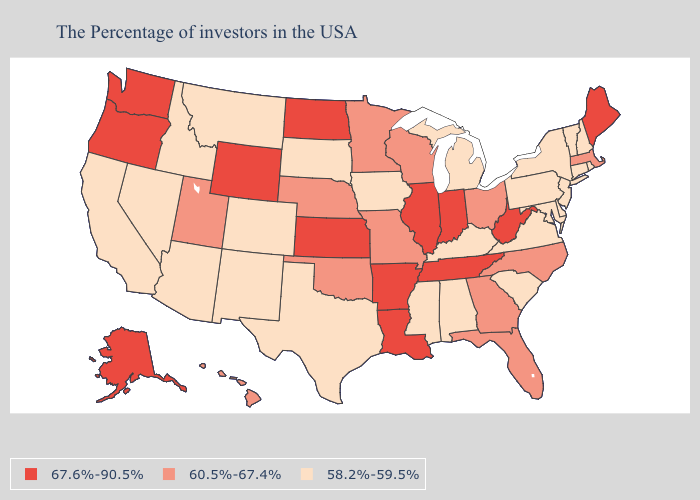Name the states that have a value in the range 60.5%-67.4%?
Keep it brief. Massachusetts, North Carolina, Ohio, Florida, Georgia, Wisconsin, Missouri, Minnesota, Nebraska, Oklahoma, Utah, Hawaii. Name the states that have a value in the range 60.5%-67.4%?
Be succinct. Massachusetts, North Carolina, Ohio, Florida, Georgia, Wisconsin, Missouri, Minnesota, Nebraska, Oklahoma, Utah, Hawaii. Does Rhode Island have a higher value than Montana?
Concise answer only. No. What is the value of Kansas?
Write a very short answer. 67.6%-90.5%. Among the states that border Colorado , does Nebraska have the highest value?
Be succinct. No. Does the first symbol in the legend represent the smallest category?
Quick response, please. No. What is the lowest value in the USA?
Write a very short answer. 58.2%-59.5%. What is the value of Maryland?
Concise answer only. 58.2%-59.5%. Name the states that have a value in the range 60.5%-67.4%?
Quick response, please. Massachusetts, North Carolina, Ohio, Florida, Georgia, Wisconsin, Missouri, Minnesota, Nebraska, Oklahoma, Utah, Hawaii. What is the value of Louisiana?
Write a very short answer. 67.6%-90.5%. What is the value of Kansas?
Quick response, please. 67.6%-90.5%. What is the lowest value in states that border New Jersey?
Give a very brief answer. 58.2%-59.5%. Which states have the highest value in the USA?
Give a very brief answer. Maine, West Virginia, Indiana, Tennessee, Illinois, Louisiana, Arkansas, Kansas, North Dakota, Wyoming, Washington, Oregon, Alaska. Which states have the highest value in the USA?
Be succinct. Maine, West Virginia, Indiana, Tennessee, Illinois, Louisiana, Arkansas, Kansas, North Dakota, Wyoming, Washington, Oregon, Alaska. Name the states that have a value in the range 67.6%-90.5%?
Keep it brief. Maine, West Virginia, Indiana, Tennessee, Illinois, Louisiana, Arkansas, Kansas, North Dakota, Wyoming, Washington, Oregon, Alaska. 